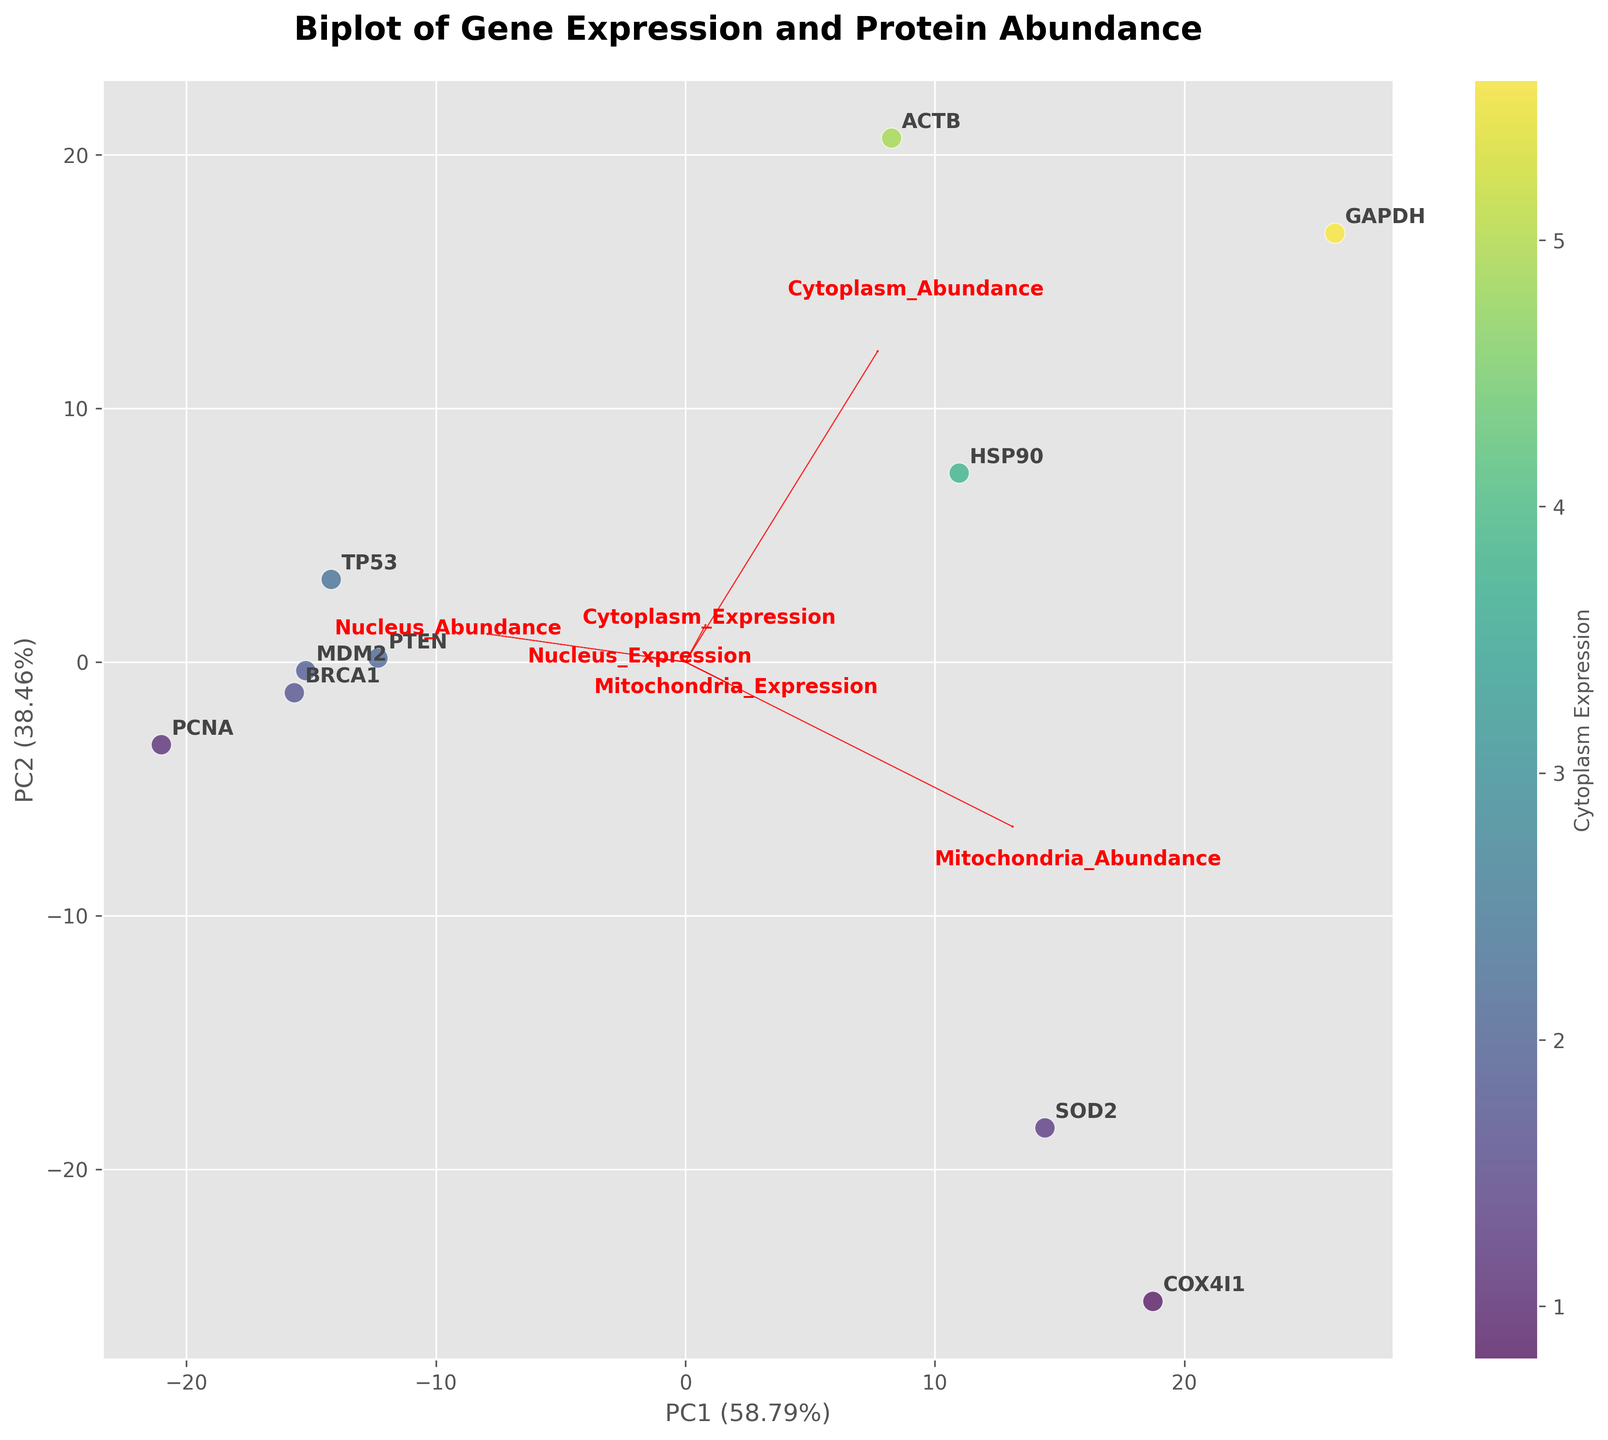Which gene has the highest cytoplasm expression on the scatter plot? Locate the gene with the highest value along the color gradient indicating cytoplasm expression. The gene with the darkest/most intense color represents the highest expression.
Answer: GAPDH What proportion of the variation in the data is explained by PC1? Refer to the x-axis label, which includes the percentage of explained variance for PC1.
Answer: ~63.1% What is the direction of the arrow representing nucleus abundance? Look for the arrow labeled "Nucleus_Abundance" that points from the origin. Determine its orientation by visualizing its direction in the biplot.
Answer: Upward and slightly to the right Which gene has the closest proximity to the origin in the biplot? Identify the gene whose point is nearest to the center (origin) of the plot. This can be judged by the Euclidean distance in the biplot.
Answer: BRCA1 Which cellular compartment feature has the most extended arrow, indicating it contributes significantly to the first two principal components? Compare the lengths of all arrows representing features such as Cytoplasm_Expression, Nucleus_Expression, Mitochondria_Expression, Cytoplasm_Abundance, Nucleus_Abundance, and Mitochondria_Abundance. The longest arrow contributes the most.
Answer: Cytoplasm_Abundance Does the expression of GAPDH correlate more with cytoplasm abundance or mitochondria abundance? Examine the positions of GAPDH relative to the arrows for "Cytoplasm_Abundance" and "Mitochondria_Abundance". GAPDH's proximity and alignment direction with the arrows indicate correlation.
Answer: Cytoplasm Abundance Which gene exhibits the highest nucleus expression according to the biplot? Identify the gene located nearest to the feature arrow labeled "Nucleus_Expression." This gene will have a high value for nucleus expression.
Answer: PCNA How do cytoplasm expression and mitochondria expression relate in the context of gene COX4I1? Observe the position of COX4I1 relative to the arrows for "Cytoplasm_Expression" and "Mitochondria_Expression." Check if it lies closer to one of the axes or further from them.
Answer: Higher in Mitochondria Expression, Lower in Cytoplasm Expression Between TP53 and HSP90, which gene has a higher mitochondria abundance? Look at the points for TP53 and HSP90 and compare their locations relative to the arrow "Mitochondria_Abundance." The gene closer to the arrow points indicates higher abundance.
Answer: HSP90 What can you infer about the overall relationship between cytoplasm abundance and mitochondria expression in this dataset? Analyze the directions and placements of the arrows for "Cytoplasm_Abundance" and "Mitochondria_Expression" to see if they align or diverge. Also, compare the clustering of genes around these arrows.
Answer: Generally, genes with higher cytoplasm abundance tend to have lower mitochondria expression 